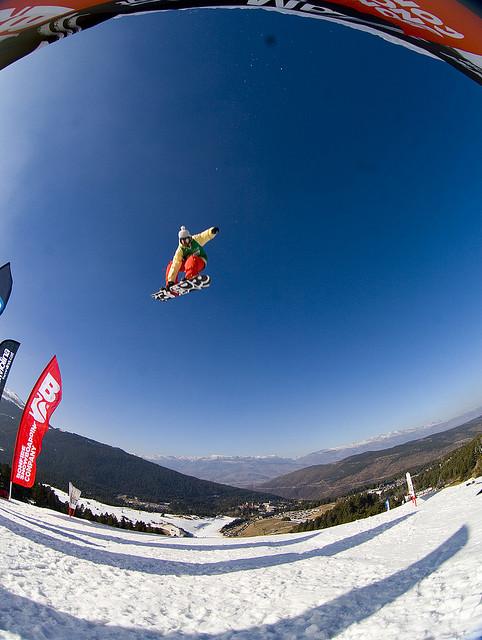Is this a snowboarder?
Give a very brief answer. Yes. What substance is covering the ground?
Be succinct. Snow. How many hands is the snowboarder using to grab his snowboard?
Keep it brief. 1. 